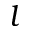Convert formula to latex. <formula><loc_0><loc_0><loc_500><loc_500>l</formula> 